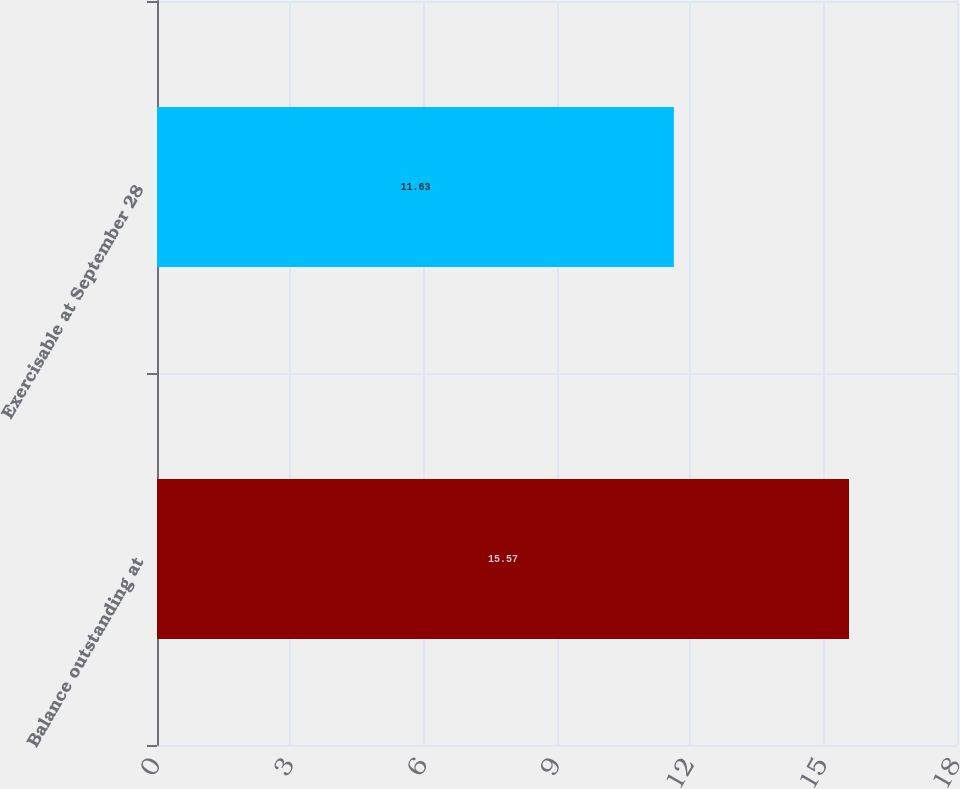Convert chart. <chart><loc_0><loc_0><loc_500><loc_500><bar_chart><fcel>Balance outstanding at<fcel>Exercisable at September 28<nl><fcel>15.57<fcel>11.63<nl></chart> 